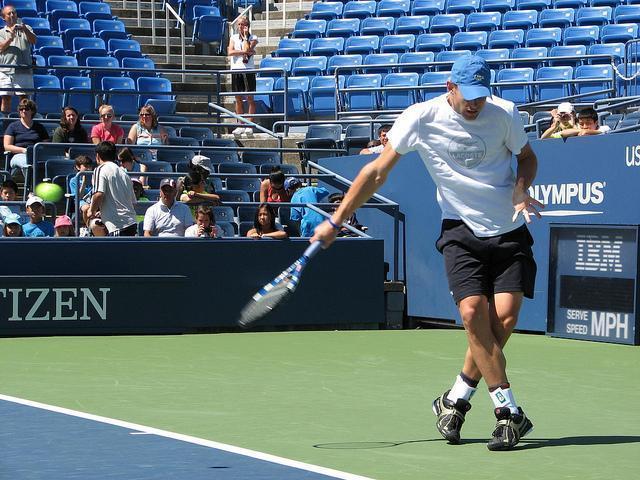How many people are there?
Give a very brief answer. 5. How many orange and white cats are in the image?
Give a very brief answer. 0. 